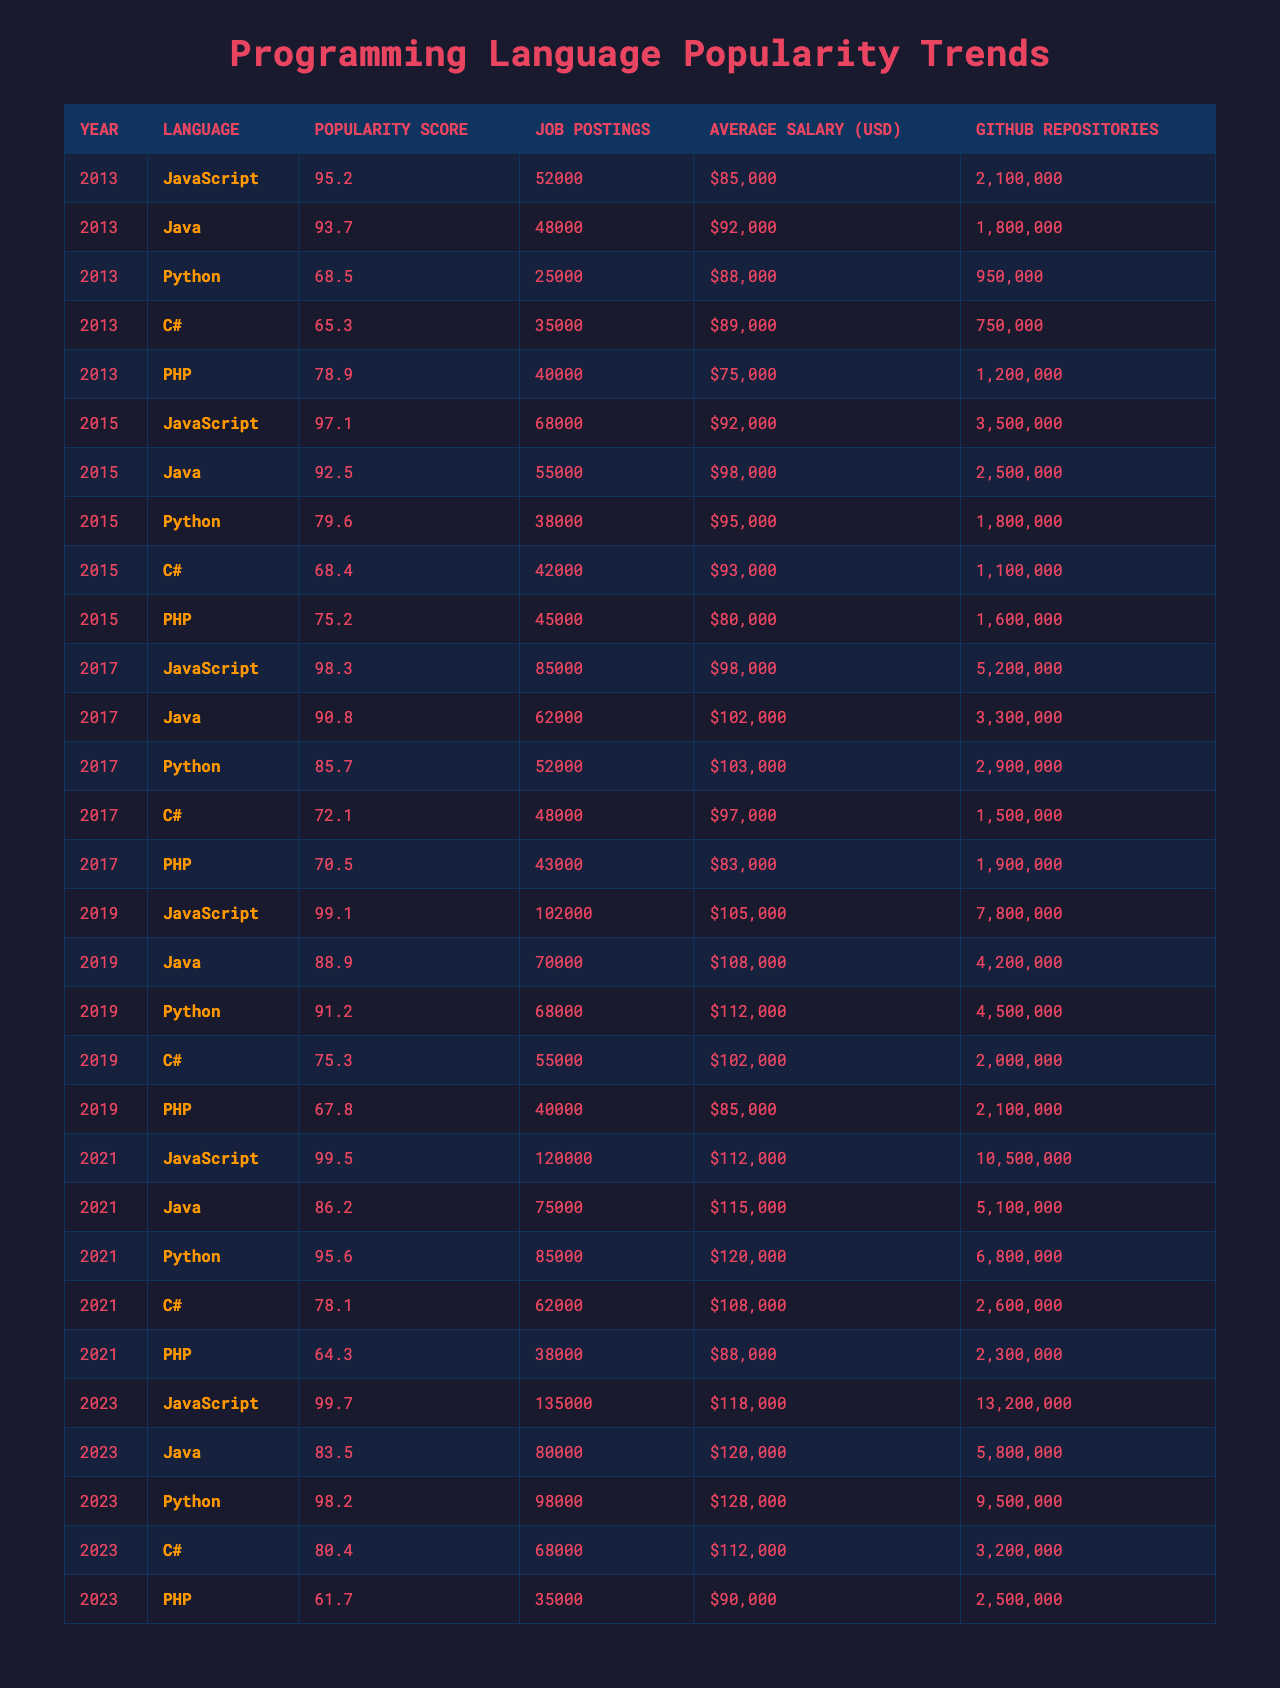What was the popularity score of Python in 2021? The table shows that in the year 2021, Python had a popularity score of 95.6.
Answer: 95.6 Which programming language had the highest average salary in 2019? According to the table for the year 2019, Python had the highest average salary listed at $112,000.
Answer: Python How many job postings were there for JavaScript in 2023? The table indicates that there were 135,000 job postings for JavaScript in 2023.
Answer: 135,000 What is the difference in popularity score between Java in 2013 and 2023? The popularity score for Java in 2013 was 93.7, and in 2023, it was 83.5. The difference is 93.7 - 83.5 = 10.2.
Answer: 10.2 Which language had the most GitHub repositories in 2021? In 2021, JavaScript had the most GitHub repositories with a total of 10,500,000.
Answer: JavaScript Is it true that PHP had more job postings than C# in 2019? The table shows PHP had 40,000 job postings while C# had 55,000 in 2019, which means this statement is false.
Answer: False What was the trend in JavaScript's popularity score from 2013 to 2023? JavaScript's popularity score increased from 95.2 in 2013 to 99.7 in 2023, indicating a positive trend.
Answer: Positive trend Calculate the average job postings for Python over all the years listed. The job postings for Python over the years are 25,000 (2013) + 38,000 (2015) + 52,000 (2017) + 68,000 (2019) + 85,000 (2021) + 98,000 (2023) = 366,000. Dividing this by 6 gives an average of 61,000 job postings.
Answer: 61,000 Which year saw the lowest average salary for PHP? From the table, the average salary for PHP in 2023 and years prior (61.7, 64.3, 75.2, etc.) suggests that 2023 had the lowest average salary at $90,000.
Answer: 2023 What is the overall trend in GitHub repositories for Python from 2013 to 2023? The number of GitHub repositories for Python increased from 950,000 in 2013 to 9,500,000 in 2023, showing a strong upward trend.
Answer: Upward trend 